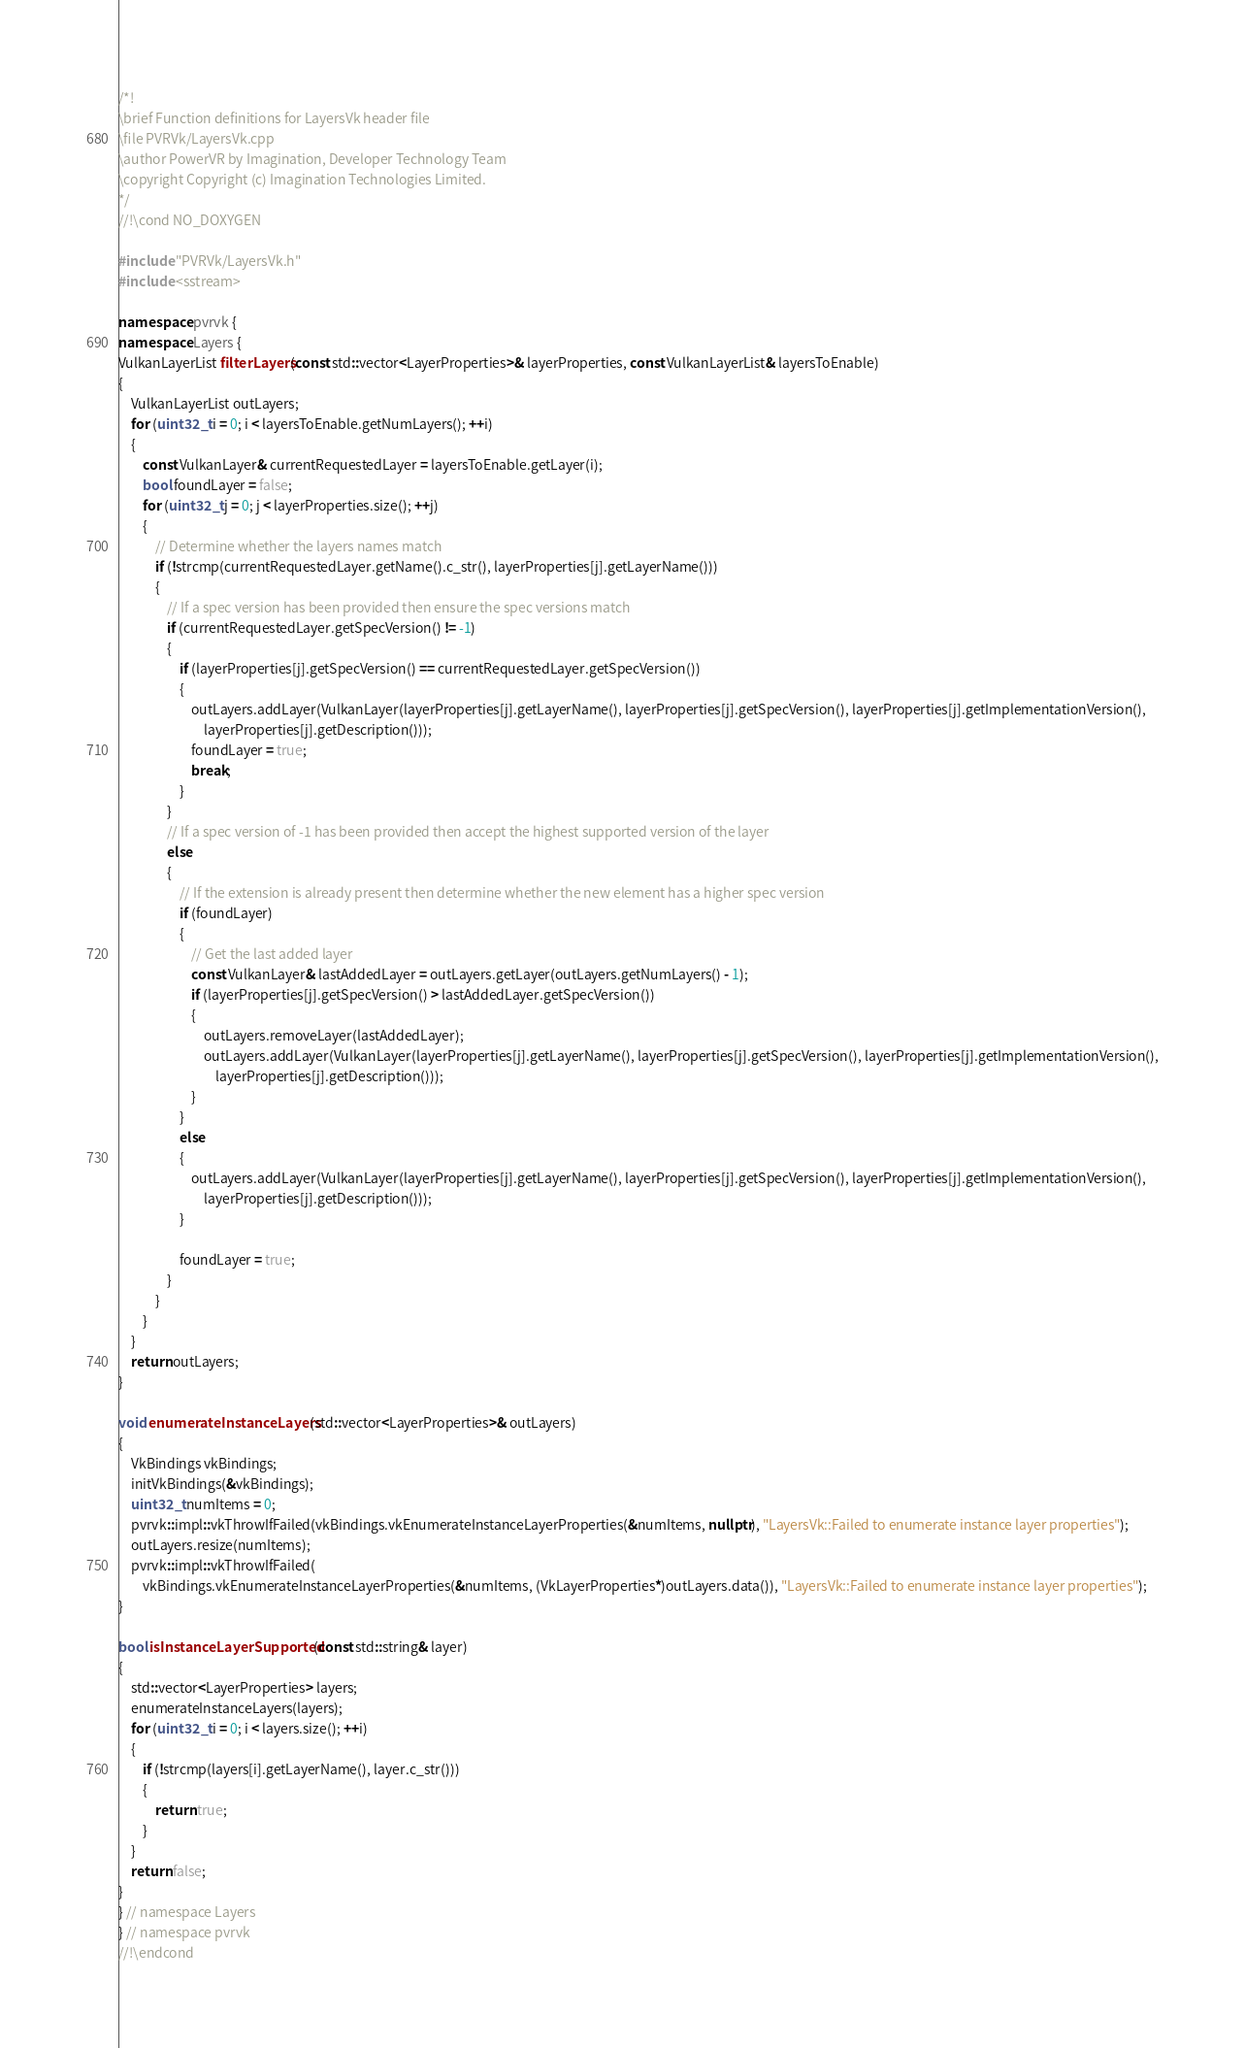Convert code to text. <code><loc_0><loc_0><loc_500><loc_500><_C++_>/*!
\brief Function definitions for LayersVk header file
\file PVRVk/LayersVk.cpp
\author PowerVR by Imagination, Developer Technology Team
\copyright Copyright (c) Imagination Technologies Limited.
*/
//!\cond NO_DOXYGEN

#include "PVRVk/LayersVk.h"
#include <sstream>

namespace pvrvk {
namespace Layers {
VulkanLayerList filterLayers(const std::vector<LayerProperties>& layerProperties, const VulkanLayerList& layersToEnable)
{
	VulkanLayerList outLayers;
	for (uint32_t i = 0; i < layersToEnable.getNumLayers(); ++i)
	{
		const VulkanLayer& currentRequestedLayer = layersToEnable.getLayer(i);
		bool foundLayer = false;
		for (uint32_t j = 0; j < layerProperties.size(); ++j)
		{
			// Determine whether the layers names match
			if (!strcmp(currentRequestedLayer.getName().c_str(), layerProperties[j].getLayerName()))
			{
				// If a spec version has been provided then ensure the spec versions match
				if (currentRequestedLayer.getSpecVersion() != -1)
				{
					if (layerProperties[j].getSpecVersion() == currentRequestedLayer.getSpecVersion())
					{
						outLayers.addLayer(VulkanLayer(layerProperties[j].getLayerName(), layerProperties[j].getSpecVersion(), layerProperties[j].getImplementationVersion(),
							layerProperties[j].getDescription()));
						foundLayer = true;
						break;
					}
				}
				// If a spec version of -1 has been provided then accept the highest supported version of the layer
				else
				{
					// If the extension is already present then determine whether the new element has a higher spec version
					if (foundLayer)
					{
						// Get the last added layer
						const VulkanLayer& lastAddedLayer = outLayers.getLayer(outLayers.getNumLayers() - 1);
						if (layerProperties[j].getSpecVersion() > lastAddedLayer.getSpecVersion())
						{
							outLayers.removeLayer(lastAddedLayer);
							outLayers.addLayer(VulkanLayer(layerProperties[j].getLayerName(), layerProperties[j].getSpecVersion(), layerProperties[j].getImplementationVersion(),
								layerProperties[j].getDescription()));
						}
					}
					else
					{
						outLayers.addLayer(VulkanLayer(layerProperties[j].getLayerName(), layerProperties[j].getSpecVersion(), layerProperties[j].getImplementationVersion(),
							layerProperties[j].getDescription()));
					}

					foundLayer = true;
				}
			}
		}
	}
	return outLayers;
}

void enumerateInstanceLayers(std::vector<LayerProperties>& outLayers)
{
	VkBindings vkBindings;
	initVkBindings(&vkBindings);
	uint32_t numItems = 0;
	pvrvk::impl::vkThrowIfFailed(vkBindings.vkEnumerateInstanceLayerProperties(&numItems, nullptr), "LayersVk::Failed to enumerate instance layer properties");
	outLayers.resize(numItems);
	pvrvk::impl::vkThrowIfFailed(
		vkBindings.vkEnumerateInstanceLayerProperties(&numItems, (VkLayerProperties*)outLayers.data()), "LayersVk::Failed to enumerate instance layer properties");
}

bool isInstanceLayerSupported(const std::string& layer)
{
	std::vector<LayerProperties> layers;
	enumerateInstanceLayers(layers);
	for (uint32_t i = 0; i < layers.size(); ++i)
	{
		if (!strcmp(layers[i].getLayerName(), layer.c_str()))
		{
			return true;
		}
	}
	return false;
}
} // namespace Layers
} // namespace pvrvk
//!\endcond
</code> 